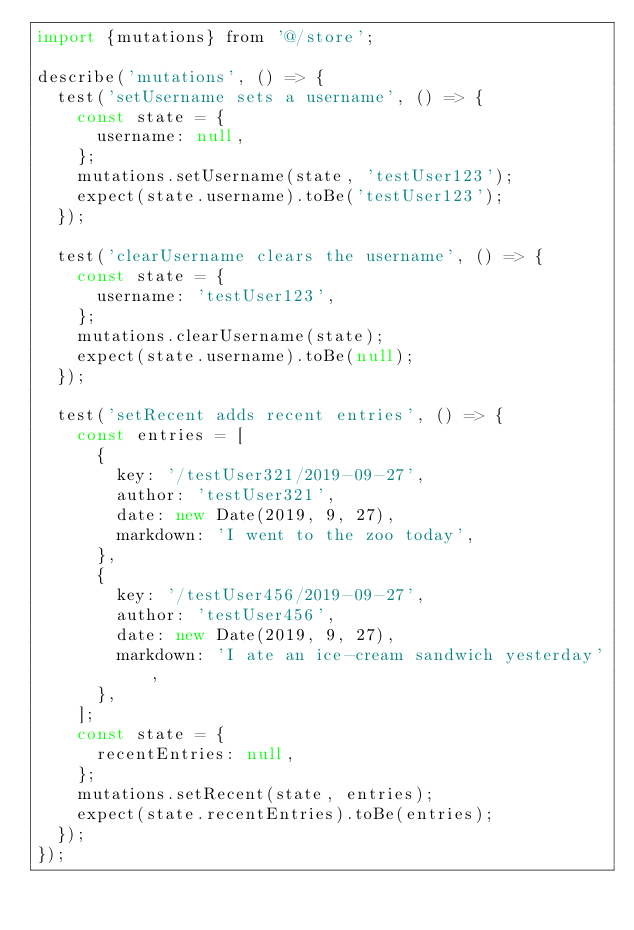<code> <loc_0><loc_0><loc_500><loc_500><_JavaScript_>import {mutations} from '@/store';

describe('mutations', () => {
  test('setUsername sets a username', () => {
    const state = {
      username: null,
    };
    mutations.setUsername(state, 'testUser123');
    expect(state.username).toBe('testUser123');
  });

  test('clearUsername clears the username', () => {
    const state = {
      username: 'testUser123',
    };
    mutations.clearUsername(state);
    expect(state.username).toBe(null);
  });

  test('setRecent adds recent entries', () => {
    const entries = [
      {
        key: '/testUser321/2019-09-27',
        author: 'testUser321',
        date: new Date(2019, 9, 27),
        markdown: 'I went to the zoo today',
      },
      {
        key: '/testUser456/2019-09-27',
        author: 'testUser456',
        date: new Date(2019, 9, 27),
        markdown: 'I ate an ice-cream sandwich yesterday',
      },
    ];
    const state = {
      recentEntries: null,
    };
    mutations.setRecent(state, entries);
    expect(state.recentEntries).toBe(entries);
  });
});
</code> 